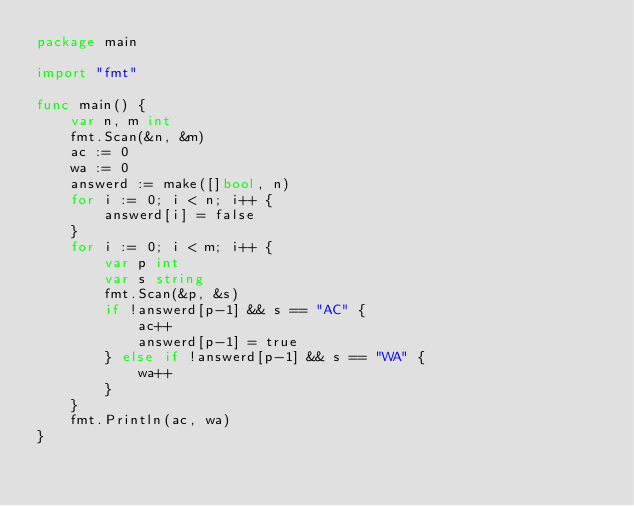<code> <loc_0><loc_0><loc_500><loc_500><_Go_>package main

import "fmt"

func main() {
	var n, m int
	fmt.Scan(&n, &m)
	ac := 0
	wa := 0
	answerd := make([]bool, n)
	for i := 0; i < n; i++ {
		answerd[i] = false
	}
	for i := 0; i < m; i++ {
		var p int
		var s string
		fmt.Scan(&p, &s)
		if !answerd[p-1] && s == "AC" {
			ac++
			answerd[p-1] = true
		} else if !answerd[p-1] && s == "WA" {
			wa++
		}
	}
	fmt.Println(ac, wa)
}
</code> 